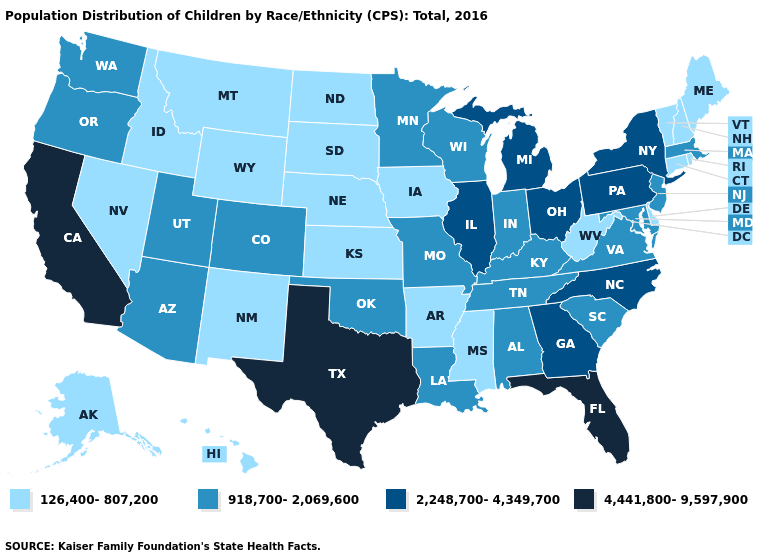What is the value of Maryland?
Concise answer only. 918,700-2,069,600. What is the value of Pennsylvania?
Short answer required. 2,248,700-4,349,700. Name the states that have a value in the range 2,248,700-4,349,700?
Give a very brief answer. Georgia, Illinois, Michigan, New York, North Carolina, Ohio, Pennsylvania. What is the highest value in the West ?
Quick response, please. 4,441,800-9,597,900. Among the states that border New Hampshire , does Maine have the highest value?
Write a very short answer. No. Name the states that have a value in the range 4,441,800-9,597,900?
Give a very brief answer. California, Florida, Texas. Is the legend a continuous bar?
Short answer required. No. Does South Dakota have the highest value in the USA?
Quick response, please. No. Does Michigan have the same value as Colorado?
Be succinct. No. Among the states that border Montana , which have the highest value?
Answer briefly. Idaho, North Dakota, South Dakota, Wyoming. What is the value of Louisiana?
Answer briefly. 918,700-2,069,600. What is the value of South Carolina?
Answer briefly. 918,700-2,069,600. Does Rhode Island have the highest value in the Northeast?
Write a very short answer. No. Which states have the lowest value in the Northeast?
Short answer required. Connecticut, Maine, New Hampshire, Rhode Island, Vermont. Name the states that have a value in the range 918,700-2,069,600?
Quick response, please. Alabama, Arizona, Colorado, Indiana, Kentucky, Louisiana, Maryland, Massachusetts, Minnesota, Missouri, New Jersey, Oklahoma, Oregon, South Carolina, Tennessee, Utah, Virginia, Washington, Wisconsin. 